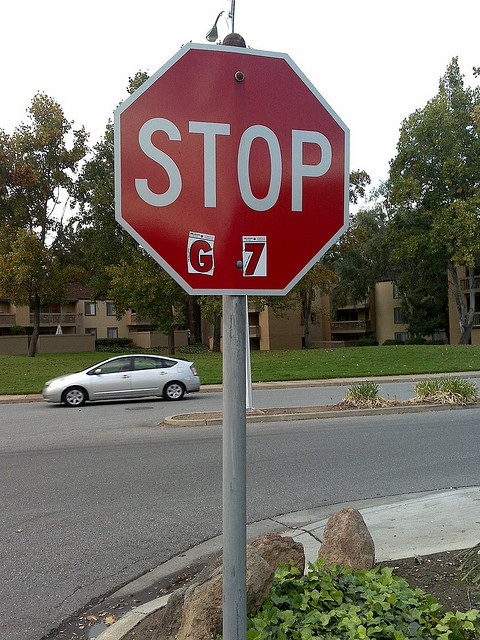Describe the objects in this image and their specific colors. I can see stop sign in white, maroon, darkgray, and brown tones and car in white, gray, lightgray, darkgray, and black tones in this image. 